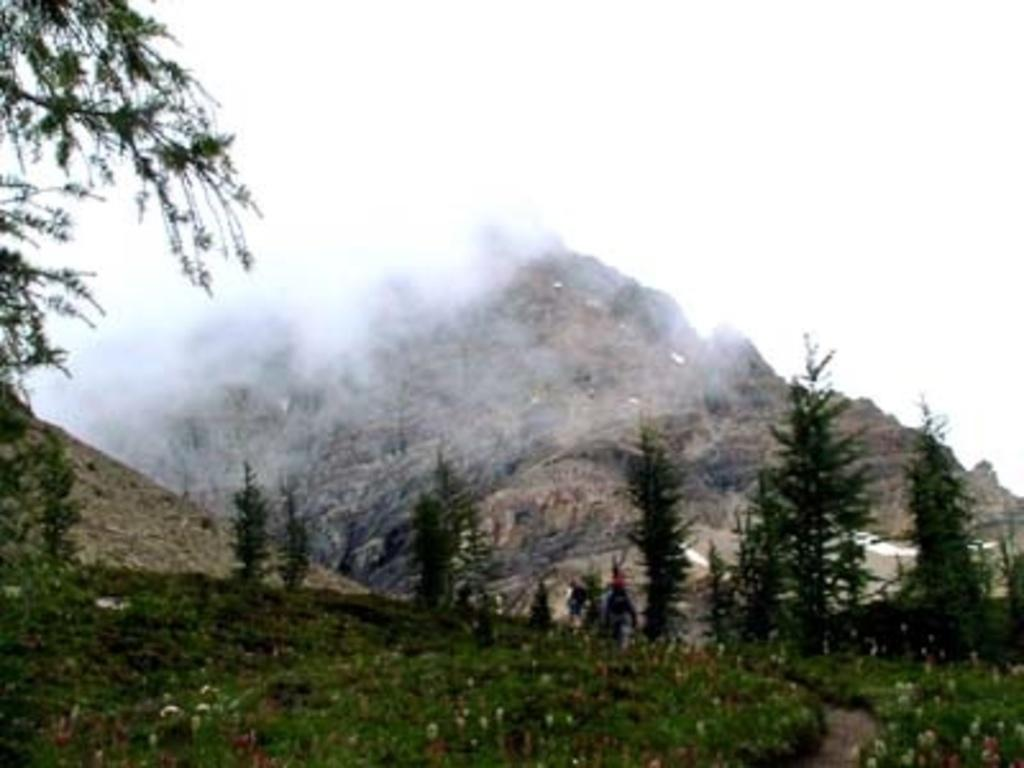What type of natural elements can be seen at the bottom of the image? There are plants and trees on the ground at the bottom of the image. What type of landscape feature is visible in the background of the image? There are mountains in the background of the image. What can be seen in the sky in the image? There are clouds in the sky in the image. Can you tell me how many desks are visible in the image? There are no desks present in the image; it features plants, trees, mountains, and clouds. What type of space vehicle can be seen in the image? There is no space vehicle present in the image; it features plants, trees, mountains, and clouds. 